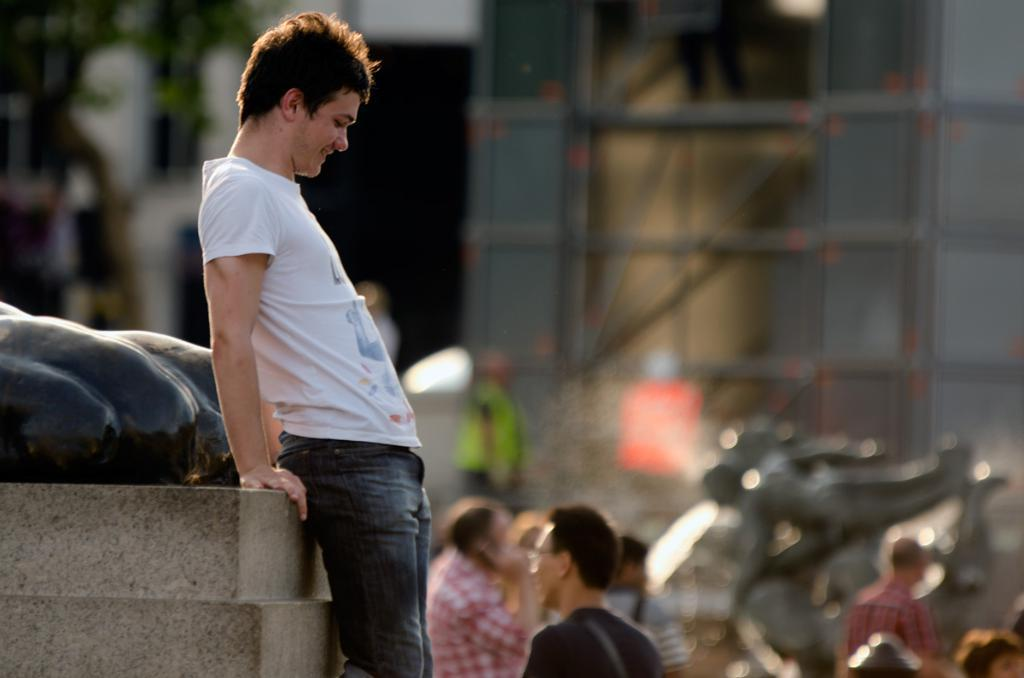What is the main subject on the left side of the image? There is a person standing at a statue on the left side of the image. What can be seen in the background of the image? There are persons, statues, a tree, and buildings in the background of the image. What type of spoon is being used to trim the bushes in the image? There are no bushes or spoons present in the image. 